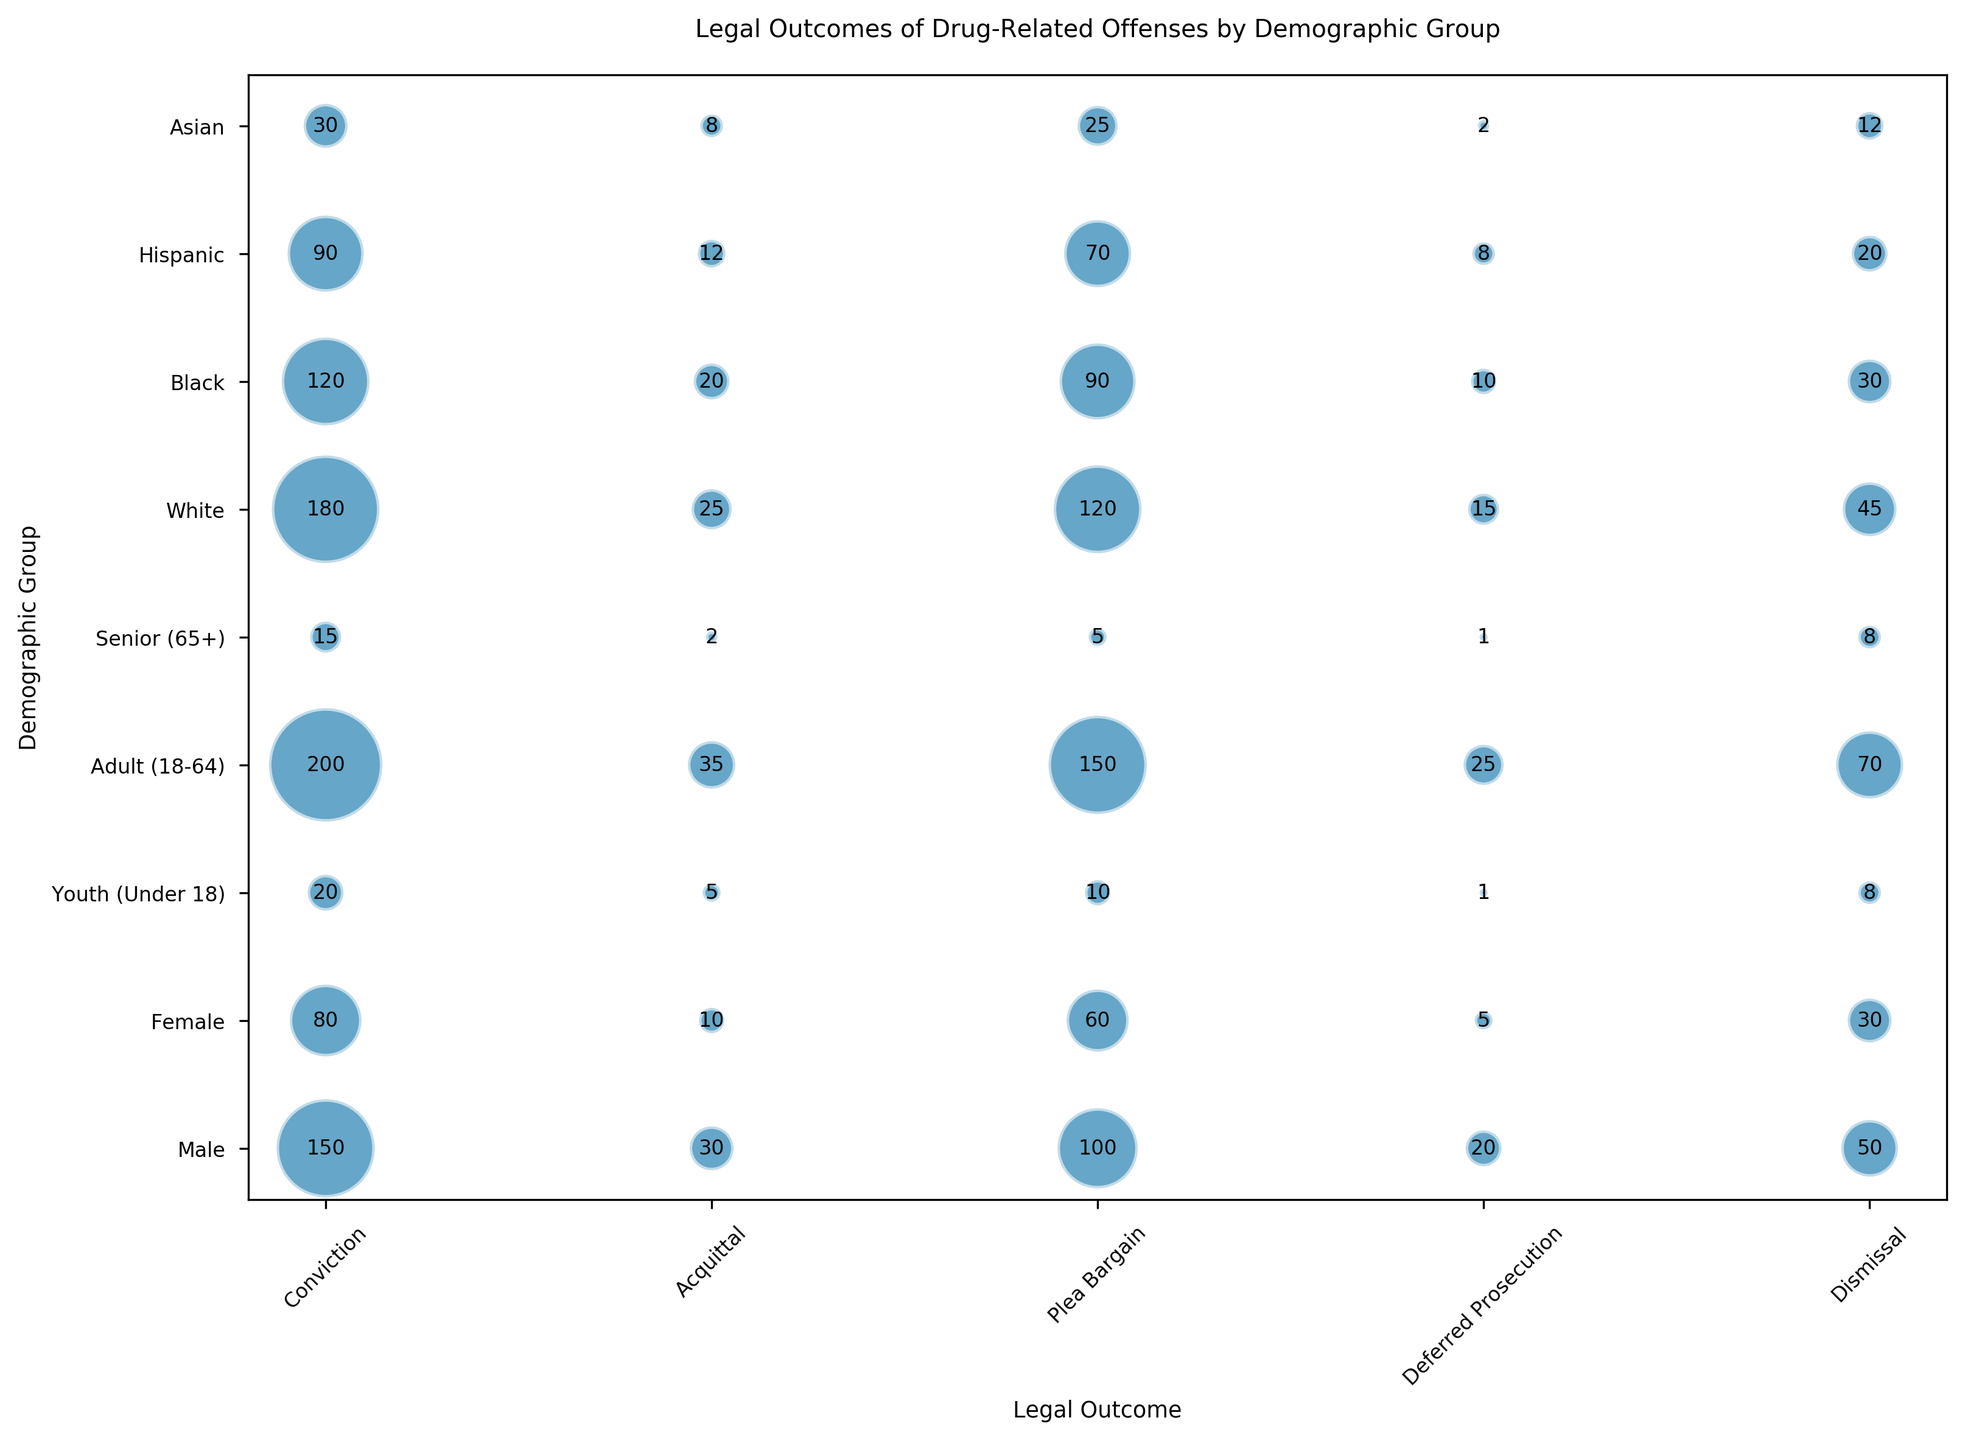Which demographic group has the highest frequency of convictions? The demographic groups are represented on the y-axis, and convictions are represented by bubbles positioned at the "Conviction" mark on the x-axis. The bubble with the largest size (indicative of frequency) corresponds to the Adult (18-64) group.
Answer: Adult (18-64) What is the combined frequency of dismissals across all demographic groups? Locate all bubbles positioned at the "Dismissal" mark on the x-axis. Sum their frequencies: Male (50), Female (30), Youth (8), Adult (70), Senior (8), White (45), Black (30), Hispanic (20), Asian (12). Therefore, 50 + 30 + 8 + 70 + 8 + 45 + 30 + 20 + 12 = 273.
Answer: 273 Which demographic group is least frequently associated with deferred prosecution? For deferred prosecution, observe the bubble sizes at the "Deferred Prosecution" mark. The smallest bubble corresponds to both Youth (Under 18) and Senior (65+), each with a frequency of 1.
Answer: Youth (Under 18) and Senior (65+) How does the frequency of plea bargains for males compare to females? Locate the "Plea Bargain" mark on the x-axis and compare the bubble sizes for Male (100) and Female (60). Males have a higher frequency of plea bargains.
Answer: Higher for males Which legal outcome is most frequent for Black individuals? For Black individuals, observe the different bubbles along the x-axis for their demographic group. The largest bubble for Black individuals is at the "Conviction" mark with a frequency of 120.
Answer: Conviction How does the frequency of convictions for seniors compare to youths? Locating the bubbles at the "Conviction" mark for Senior (65+) and Youth (Under 18), compare the sizes. Seniors have a frequency of 15, while youths have a frequency of 20.
Answer: Higher for youths What is the overall frequency of acquittals across gender categories (male and female)? Locate the "Acquittal" bubbles for Male (30) and Female (10). Sum the frequencies: 30 + 10 = 40.
Answer: 40 What are the frequencies of all legal outcomes for the Hispanic demographic? Refer to the x-axis for all bubbles in the "Hispanic" row: Conviction (90), Acquittal (12), Plea Bargain (70), Deferred Prosecution (8), Dismissal (20). So, the frequencies are: 90, 12, 70, 8, 20.
Answer: 90, 12, 70, 8, 20 Where is the frequency of deferred prosecution higher, among Asians or Hispanics? Deferred prosecution bubbles for Asians (2) and Hispanics (8). The Hispanic demographic has a higher frequency.
Answer: Hispanics Between the demographic subgroups of Whites and Blacks, which has a higher frequency of dismissals? Compare the dismissal bubbles for White (45) and Black (30). The White demographic group has a higher frequency.
Answer: Whites 